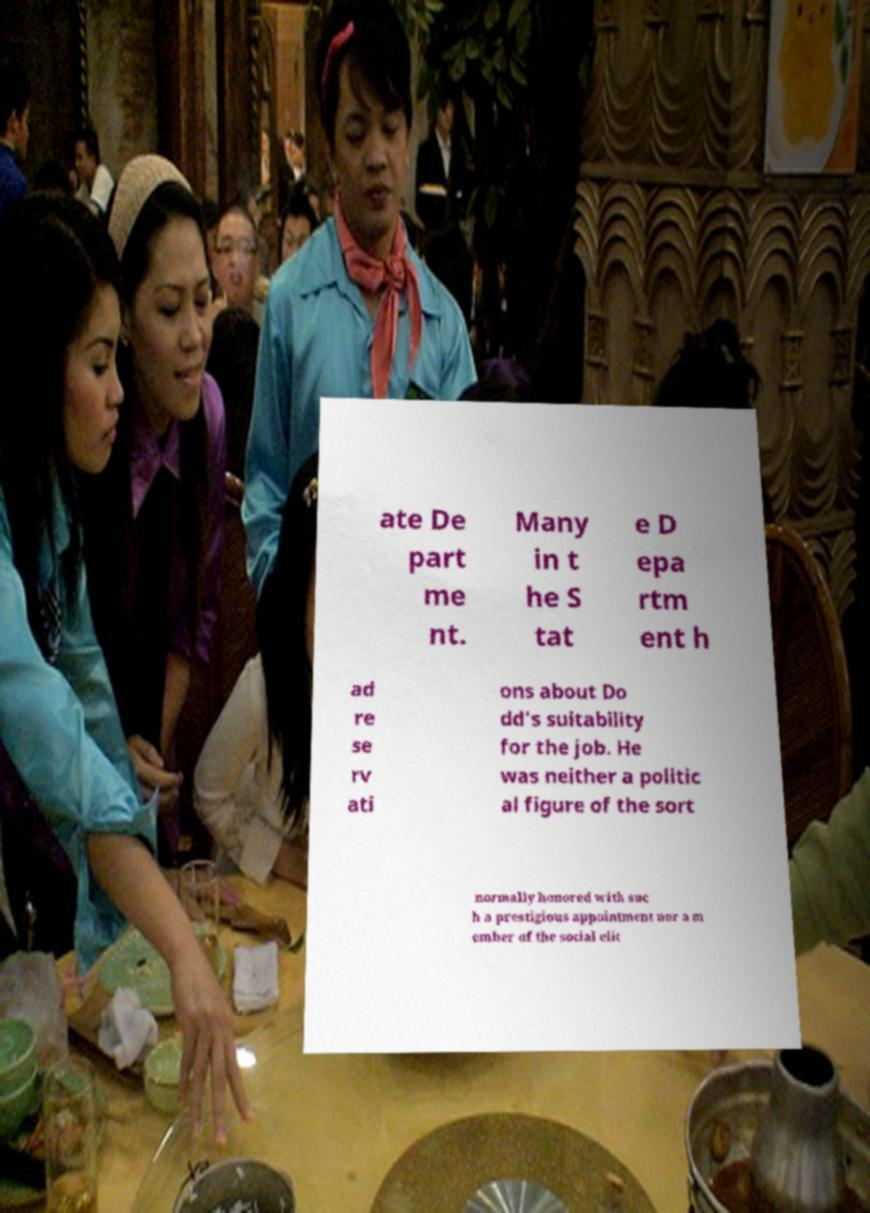Please read and relay the text visible in this image. What does it say? ate De part me nt. Many in t he S tat e D epa rtm ent h ad re se rv ati ons about Do dd's suitability for the job. He was neither a politic al figure of the sort normally honored with suc h a prestigious appointment nor a m ember of the social elit 